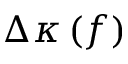Convert formula to latex. <formula><loc_0><loc_0><loc_500><loc_500>\Delta \kappa \left ( f \right )</formula> 